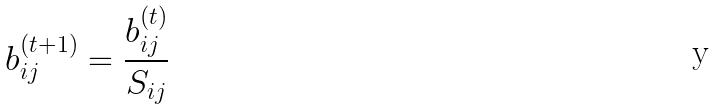<formula> <loc_0><loc_0><loc_500><loc_500>b _ { i j } ^ { ( t + 1 ) } = \frac { b _ { i j } ^ { ( t ) } } { S _ { i j } }</formula> 